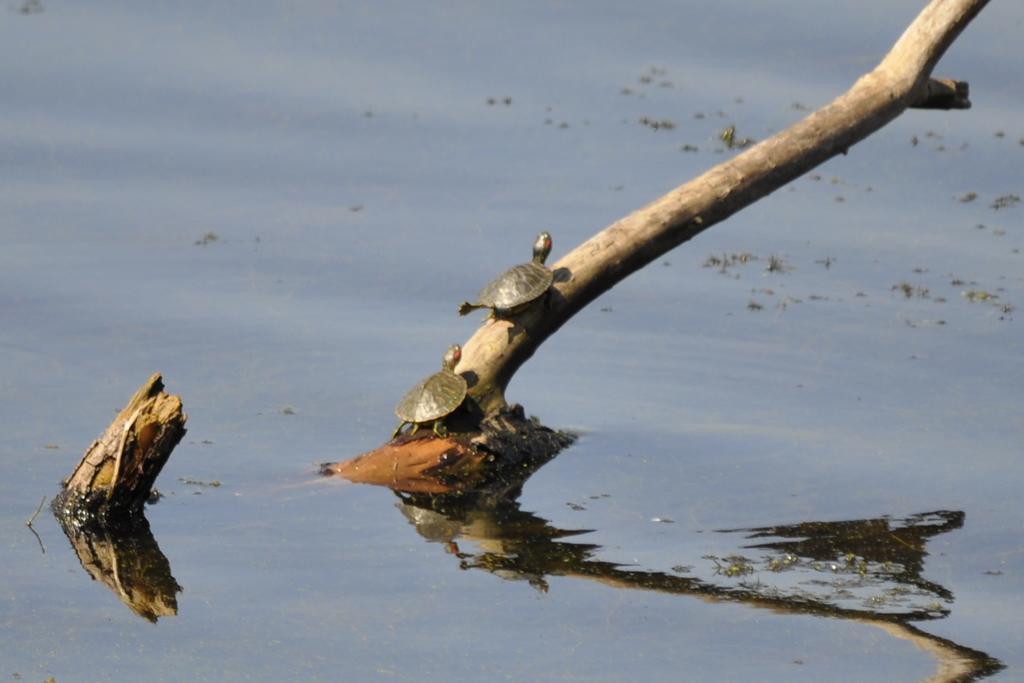Describe this image in one or two sentences. In this image, we can see tortoises on the stick and at the bottom, there is water. 